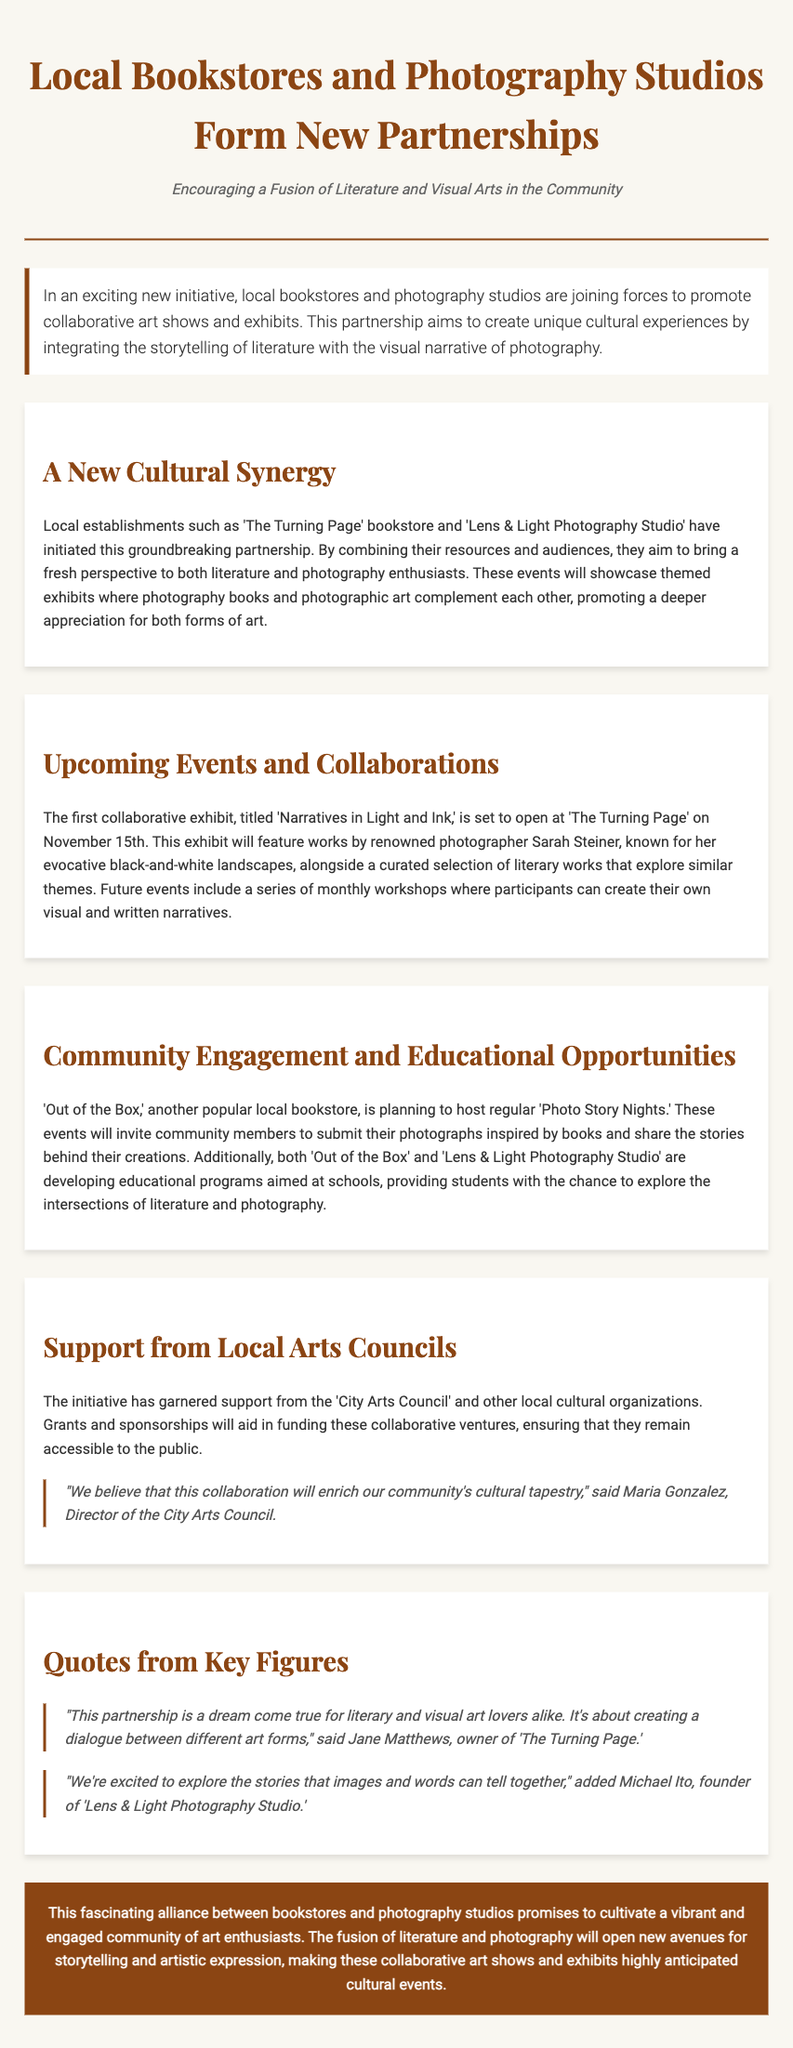What is the title of the first collaborative exhibit? The title of the first collaborative exhibit mentioned is 'Narratives in Light and Ink.'
Answer: 'Narratives in Light and Ink' When is the 'Narratives in Light and Ink' exhibit set to open? The opening date of the exhibit is specified as November 15th.
Answer: November 15th Who is the renowned photographer featured in the first exhibit? The document states that the renowned photographer featured is Sarah Steiner.
Answer: Sarah Steiner What is the main goal of the partnership between bookstores and photography studios? The partnership aims to create unique cultural experiences integrating literature and photography.
Answer: Unique cultural experiences Which bookstore is planning to host 'Photo Story Nights'? The bookstore planning to host these events is 'Out of the Box.'
Answer: 'Out of the Box' Who expressed support for the initiative from local cultural organizations? The initiative received support from the 'City Arts Council.'
Answer: City Arts Council What types of educational programs are being developed? The educational programs aim to explore the intersections of literature and photography.
Answer: Intersections of literature and photography What does Jane Matthews believe this partnership represents? Jane Matthews stated that the partnership represents a dialogue between different art forms.
Answer: Dialogue between different art forms What type of events will be held every month after the exhibit? The future events will include a series of monthly workshops.
Answer: Monthly workshops 